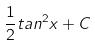<formula> <loc_0><loc_0><loc_500><loc_500>\frac { 1 } { 2 } t a n ^ { 2 } x + C</formula> 